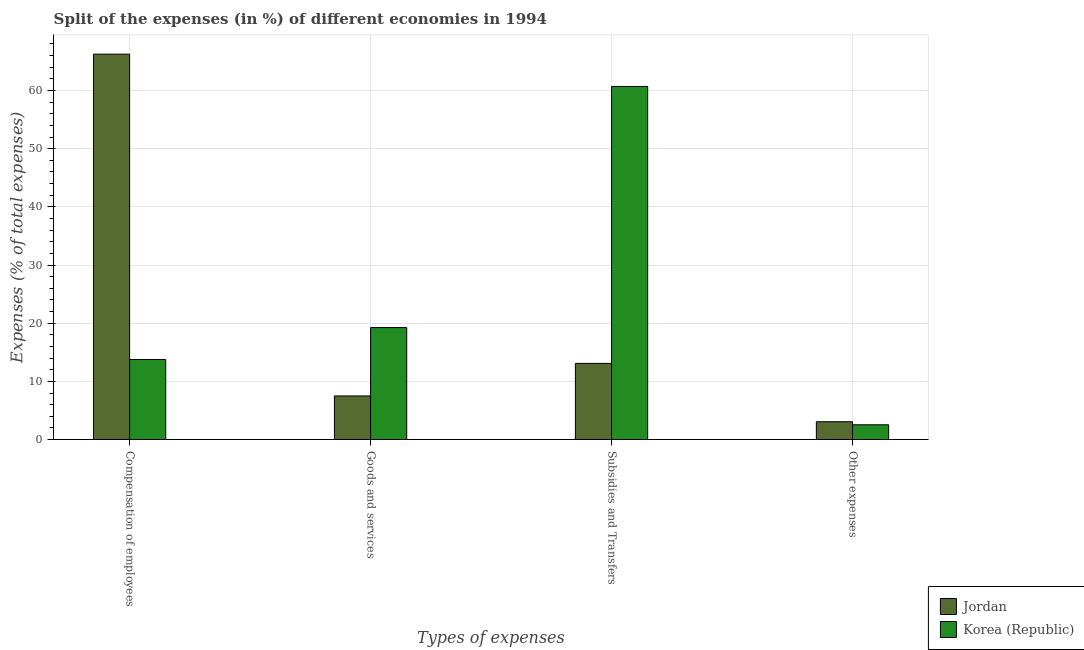How many different coloured bars are there?
Give a very brief answer. 2. How many groups of bars are there?
Provide a succinct answer. 4. Are the number of bars on each tick of the X-axis equal?
Ensure brevity in your answer.  Yes. What is the label of the 1st group of bars from the left?
Give a very brief answer. Compensation of employees. What is the percentage of amount spent on compensation of employees in Korea (Republic)?
Provide a short and direct response. 13.77. Across all countries, what is the maximum percentage of amount spent on goods and services?
Keep it short and to the point. 19.26. Across all countries, what is the minimum percentage of amount spent on other expenses?
Provide a succinct answer. 2.55. In which country was the percentage of amount spent on subsidies maximum?
Your response must be concise. Korea (Republic). What is the total percentage of amount spent on compensation of employees in the graph?
Offer a terse response. 80.02. What is the difference between the percentage of amount spent on subsidies in Korea (Republic) and that in Jordan?
Offer a terse response. 47.61. What is the difference between the percentage of amount spent on compensation of employees in Korea (Republic) and the percentage of amount spent on subsidies in Jordan?
Offer a very short reply. 0.67. What is the average percentage of amount spent on other expenses per country?
Your response must be concise. 2.81. What is the difference between the percentage of amount spent on subsidies and percentage of amount spent on other expenses in Korea (Republic)?
Your response must be concise. 58.15. What is the ratio of the percentage of amount spent on other expenses in Jordan to that in Korea (Republic)?
Your answer should be very brief. 1.21. What is the difference between the highest and the second highest percentage of amount spent on other expenses?
Your answer should be compact. 0.52. What is the difference between the highest and the lowest percentage of amount spent on other expenses?
Make the answer very short. 0.52. Is the sum of the percentage of amount spent on other expenses in Jordan and Korea (Republic) greater than the maximum percentage of amount spent on subsidies across all countries?
Your answer should be compact. No. What does the 2nd bar from the left in Other expenses represents?
Make the answer very short. Korea (Republic). What does the 2nd bar from the right in Goods and services represents?
Give a very brief answer. Jordan. Is it the case that in every country, the sum of the percentage of amount spent on compensation of employees and percentage of amount spent on goods and services is greater than the percentage of amount spent on subsidies?
Provide a succinct answer. No. How many bars are there?
Make the answer very short. 8. Are all the bars in the graph horizontal?
Your response must be concise. No. What is the difference between two consecutive major ticks on the Y-axis?
Offer a very short reply. 10. Are the values on the major ticks of Y-axis written in scientific E-notation?
Provide a succinct answer. No. Does the graph contain grids?
Offer a very short reply. Yes. How many legend labels are there?
Ensure brevity in your answer.  2. How are the legend labels stacked?
Ensure brevity in your answer.  Vertical. What is the title of the graph?
Give a very brief answer. Split of the expenses (in %) of different economies in 1994. Does "Guam" appear as one of the legend labels in the graph?
Ensure brevity in your answer.  No. What is the label or title of the X-axis?
Make the answer very short. Types of expenses. What is the label or title of the Y-axis?
Offer a very short reply. Expenses (% of total expenses). What is the Expenses (% of total expenses) in Jordan in Compensation of employees?
Provide a short and direct response. 66.25. What is the Expenses (% of total expenses) in Korea (Republic) in Compensation of employees?
Provide a short and direct response. 13.77. What is the Expenses (% of total expenses) of Jordan in Goods and services?
Ensure brevity in your answer.  7.51. What is the Expenses (% of total expenses) of Korea (Republic) in Goods and services?
Offer a terse response. 19.26. What is the Expenses (% of total expenses) in Jordan in Subsidies and Transfers?
Your response must be concise. 13.1. What is the Expenses (% of total expenses) of Korea (Republic) in Subsidies and Transfers?
Offer a terse response. 60.7. What is the Expenses (% of total expenses) of Jordan in Other expenses?
Give a very brief answer. 3.07. What is the Expenses (% of total expenses) in Korea (Republic) in Other expenses?
Your answer should be very brief. 2.55. Across all Types of expenses, what is the maximum Expenses (% of total expenses) in Jordan?
Your answer should be compact. 66.25. Across all Types of expenses, what is the maximum Expenses (% of total expenses) in Korea (Republic)?
Keep it short and to the point. 60.7. Across all Types of expenses, what is the minimum Expenses (% of total expenses) of Jordan?
Give a very brief answer. 3.07. Across all Types of expenses, what is the minimum Expenses (% of total expenses) in Korea (Republic)?
Your answer should be compact. 2.55. What is the total Expenses (% of total expenses) in Jordan in the graph?
Provide a succinct answer. 89.93. What is the total Expenses (% of total expenses) in Korea (Republic) in the graph?
Provide a succinct answer. 96.27. What is the difference between the Expenses (% of total expenses) of Jordan in Compensation of employees and that in Goods and services?
Ensure brevity in your answer.  58.75. What is the difference between the Expenses (% of total expenses) in Korea (Republic) in Compensation of employees and that in Goods and services?
Provide a succinct answer. -5.49. What is the difference between the Expenses (% of total expenses) of Jordan in Compensation of employees and that in Subsidies and Transfers?
Provide a short and direct response. 53.16. What is the difference between the Expenses (% of total expenses) of Korea (Republic) in Compensation of employees and that in Subsidies and Transfers?
Provide a succinct answer. -46.94. What is the difference between the Expenses (% of total expenses) of Jordan in Compensation of employees and that in Other expenses?
Offer a very short reply. 63.18. What is the difference between the Expenses (% of total expenses) in Korea (Republic) in Compensation of employees and that in Other expenses?
Offer a terse response. 11.22. What is the difference between the Expenses (% of total expenses) of Jordan in Goods and services and that in Subsidies and Transfers?
Offer a terse response. -5.59. What is the difference between the Expenses (% of total expenses) of Korea (Republic) in Goods and services and that in Subsidies and Transfers?
Make the answer very short. -41.45. What is the difference between the Expenses (% of total expenses) of Jordan in Goods and services and that in Other expenses?
Offer a terse response. 4.43. What is the difference between the Expenses (% of total expenses) of Korea (Republic) in Goods and services and that in Other expenses?
Provide a short and direct response. 16.71. What is the difference between the Expenses (% of total expenses) in Jordan in Subsidies and Transfers and that in Other expenses?
Ensure brevity in your answer.  10.02. What is the difference between the Expenses (% of total expenses) of Korea (Republic) in Subsidies and Transfers and that in Other expenses?
Your answer should be compact. 58.15. What is the difference between the Expenses (% of total expenses) of Jordan in Compensation of employees and the Expenses (% of total expenses) of Korea (Republic) in Goods and services?
Your response must be concise. 47. What is the difference between the Expenses (% of total expenses) in Jordan in Compensation of employees and the Expenses (% of total expenses) in Korea (Republic) in Subsidies and Transfers?
Ensure brevity in your answer.  5.55. What is the difference between the Expenses (% of total expenses) in Jordan in Compensation of employees and the Expenses (% of total expenses) in Korea (Republic) in Other expenses?
Provide a succinct answer. 63.71. What is the difference between the Expenses (% of total expenses) in Jordan in Goods and services and the Expenses (% of total expenses) in Korea (Republic) in Subsidies and Transfers?
Give a very brief answer. -53.2. What is the difference between the Expenses (% of total expenses) of Jordan in Goods and services and the Expenses (% of total expenses) of Korea (Republic) in Other expenses?
Your answer should be very brief. 4.96. What is the difference between the Expenses (% of total expenses) in Jordan in Subsidies and Transfers and the Expenses (% of total expenses) in Korea (Republic) in Other expenses?
Provide a succinct answer. 10.55. What is the average Expenses (% of total expenses) in Jordan per Types of expenses?
Make the answer very short. 22.48. What is the average Expenses (% of total expenses) of Korea (Republic) per Types of expenses?
Provide a succinct answer. 24.07. What is the difference between the Expenses (% of total expenses) in Jordan and Expenses (% of total expenses) in Korea (Republic) in Compensation of employees?
Provide a succinct answer. 52.49. What is the difference between the Expenses (% of total expenses) of Jordan and Expenses (% of total expenses) of Korea (Republic) in Goods and services?
Your response must be concise. -11.75. What is the difference between the Expenses (% of total expenses) in Jordan and Expenses (% of total expenses) in Korea (Republic) in Subsidies and Transfers?
Your answer should be very brief. -47.61. What is the difference between the Expenses (% of total expenses) of Jordan and Expenses (% of total expenses) of Korea (Republic) in Other expenses?
Give a very brief answer. 0.52. What is the ratio of the Expenses (% of total expenses) of Jordan in Compensation of employees to that in Goods and services?
Offer a very short reply. 8.83. What is the ratio of the Expenses (% of total expenses) of Korea (Republic) in Compensation of employees to that in Goods and services?
Make the answer very short. 0.71. What is the ratio of the Expenses (% of total expenses) in Jordan in Compensation of employees to that in Subsidies and Transfers?
Your answer should be very brief. 5.06. What is the ratio of the Expenses (% of total expenses) in Korea (Republic) in Compensation of employees to that in Subsidies and Transfers?
Give a very brief answer. 0.23. What is the ratio of the Expenses (% of total expenses) in Jordan in Compensation of employees to that in Other expenses?
Provide a short and direct response. 21.57. What is the ratio of the Expenses (% of total expenses) of Korea (Republic) in Compensation of employees to that in Other expenses?
Keep it short and to the point. 5.4. What is the ratio of the Expenses (% of total expenses) of Jordan in Goods and services to that in Subsidies and Transfers?
Provide a short and direct response. 0.57. What is the ratio of the Expenses (% of total expenses) of Korea (Republic) in Goods and services to that in Subsidies and Transfers?
Offer a terse response. 0.32. What is the ratio of the Expenses (% of total expenses) in Jordan in Goods and services to that in Other expenses?
Provide a succinct answer. 2.44. What is the ratio of the Expenses (% of total expenses) of Korea (Republic) in Goods and services to that in Other expenses?
Provide a succinct answer. 7.56. What is the ratio of the Expenses (% of total expenses) of Jordan in Subsidies and Transfers to that in Other expenses?
Make the answer very short. 4.26. What is the ratio of the Expenses (% of total expenses) of Korea (Republic) in Subsidies and Transfers to that in Other expenses?
Keep it short and to the point. 23.82. What is the difference between the highest and the second highest Expenses (% of total expenses) in Jordan?
Provide a succinct answer. 53.16. What is the difference between the highest and the second highest Expenses (% of total expenses) of Korea (Republic)?
Offer a terse response. 41.45. What is the difference between the highest and the lowest Expenses (% of total expenses) in Jordan?
Provide a short and direct response. 63.18. What is the difference between the highest and the lowest Expenses (% of total expenses) of Korea (Republic)?
Give a very brief answer. 58.15. 